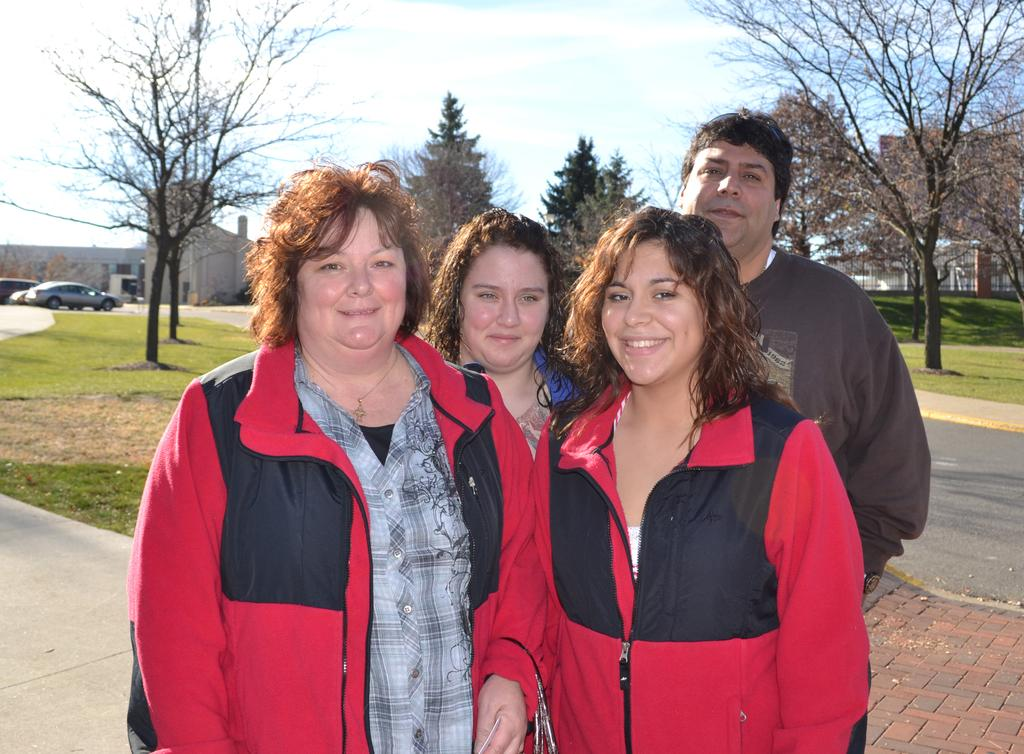How many people are in the foreground of the image? There are four people in the foreground of the image: three women in red jackets and one man in a brown T-shirt. What are the women in the foreground wearing? The women in the foreground are wearing red jackets. What can be seen in the background of the image? In the background of the image, there are buildings, trees, grass, vehicles, and the sky. What type of vehicles are visible in the background? The vehicles in the background are not specified, but they are present. Can you see any zippers on the red jackets in the image? There is no information about zippers on the red jackets in the provided facts, so it cannot be determined from the image. Are there any birds flying in the sky in the image? There is no mention of birds in the provided facts, so it cannot be determined from the image. 